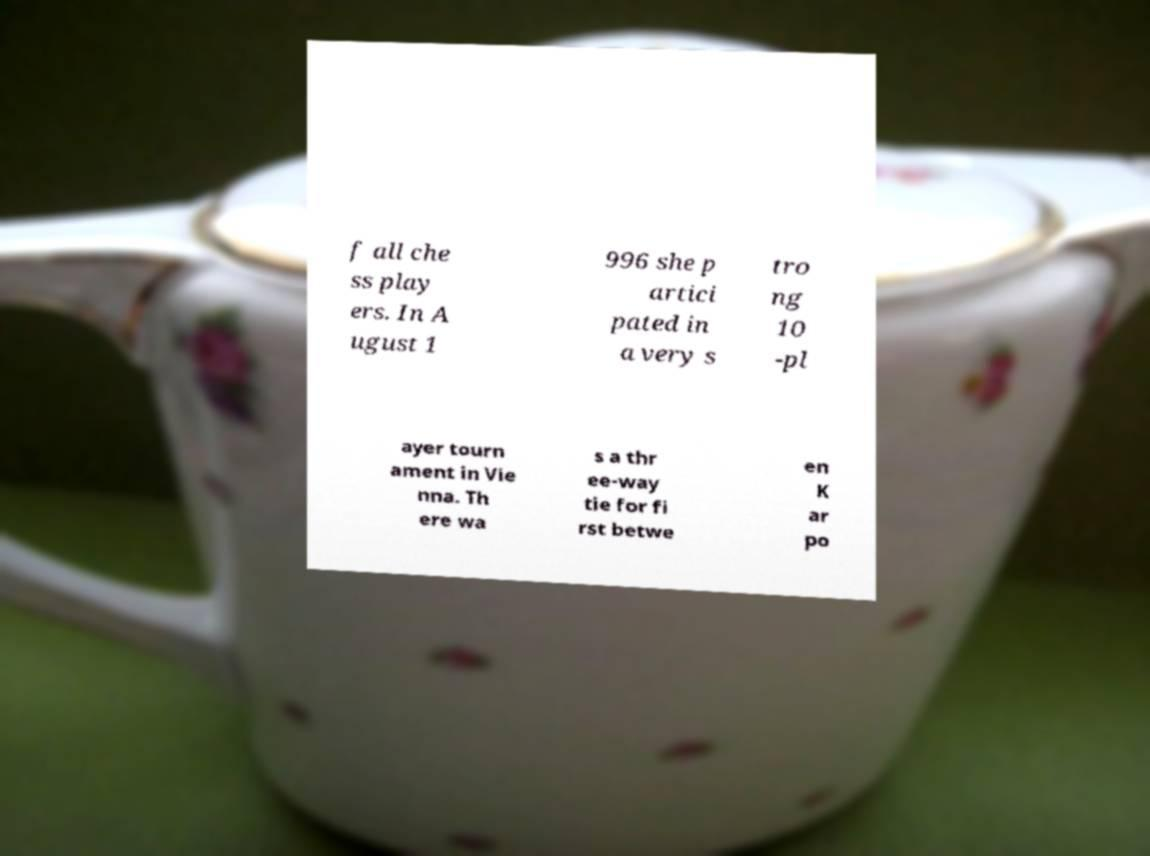Please identify and transcribe the text found in this image. f all che ss play ers. In A ugust 1 996 she p artici pated in a very s tro ng 10 -pl ayer tourn ament in Vie nna. Th ere wa s a thr ee-way tie for fi rst betwe en K ar po 